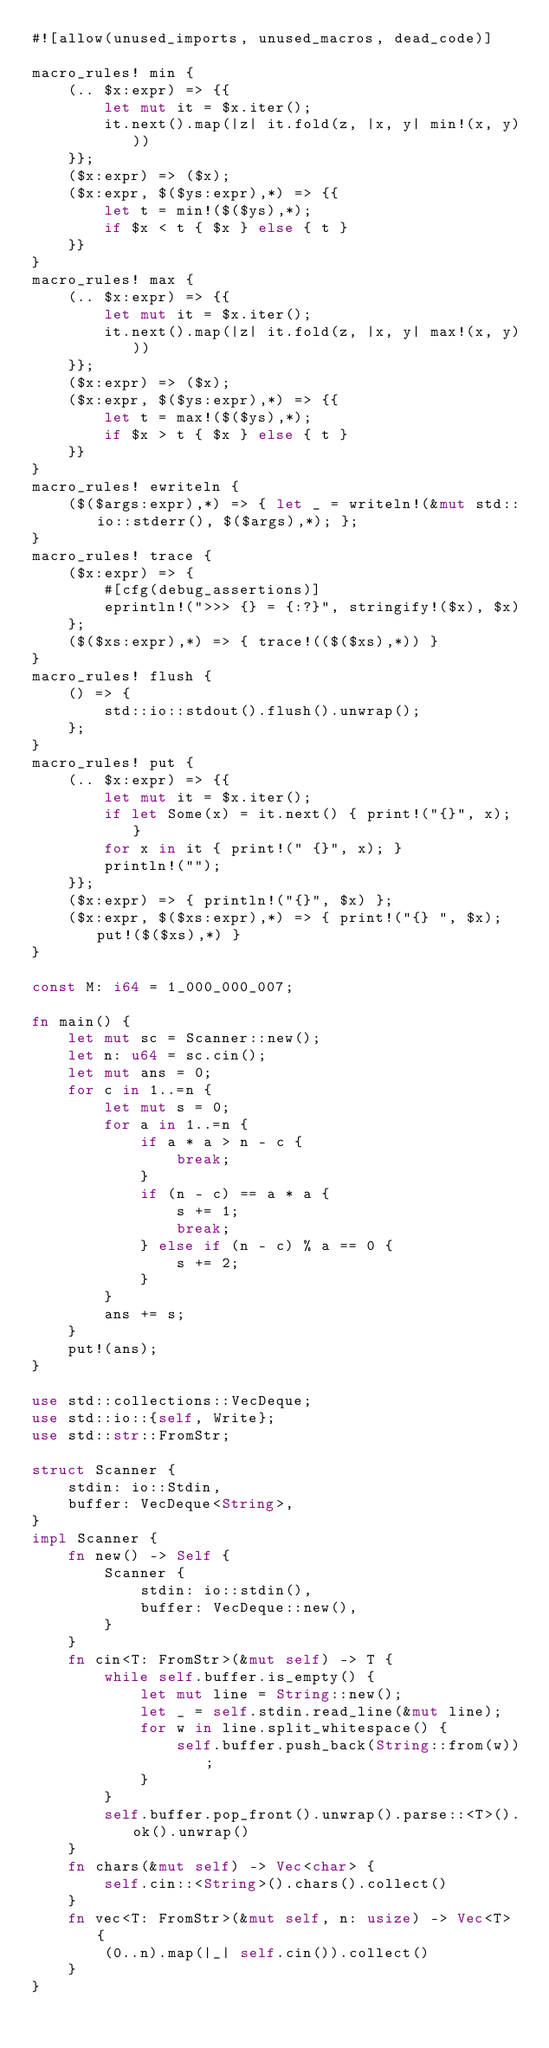<code> <loc_0><loc_0><loc_500><loc_500><_Rust_>#![allow(unused_imports, unused_macros, dead_code)]

macro_rules! min {
    (.. $x:expr) => {{
        let mut it = $x.iter();
        it.next().map(|z| it.fold(z, |x, y| min!(x, y)))
    }};
    ($x:expr) => ($x);
    ($x:expr, $($ys:expr),*) => {{
        let t = min!($($ys),*);
        if $x < t { $x } else { t }
    }}
}
macro_rules! max {
    (.. $x:expr) => {{
        let mut it = $x.iter();
        it.next().map(|z| it.fold(z, |x, y| max!(x, y)))
    }};
    ($x:expr) => ($x);
    ($x:expr, $($ys:expr),*) => {{
        let t = max!($($ys),*);
        if $x > t { $x } else { t }
    }}
}
macro_rules! ewriteln {
    ($($args:expr),*) => { let _ = writeln!(&mut std::io::stderr(), $($args),*); };
}
macro_rules! trace {
    ($x:expr) => {
        #[cfg(debug_assertions)]
        eprintln!(">>> {} = {:?}", stringify!($x), $x)
    };
    ($($xs:expr),*) => { trace!(($($xs),*)) }
}
macro_rules! flush {
    () => {
        std::io::stdout().flush().unwrap();
    };
}
macro_rules! put {
    (.. $x:expr) => {{
        let mut it = $x.iter();
        if let Some(x) = it.next() { print!("{}", x); }
        for x in it { print!(" {}", x); }
        println!("");
    }};
    ($x:expr) => { println!("{}", $x) };
    ($x:expr, $($xs:expr),*) => { print!("{} ", $x); put!($($xs),*) }
}

const M: i64 = 1_000_000_007;

fn main() {
    let mut sc = Scanner::new();
    let n: u64 = sc.cin();
    let mut ans = 0;
    for c in 1..=n {
        let mut s = 0;
        for a in 1..=n {
            if a * a > n - c {
                break;
            }
            if (n - c) == a * a {
                s += 1;
                break;
            } else if (n - c) % a == 0 {
                s += 2;
            }
        }
        ans += s;
    }
    put!(ans);
}

use std::collections::VecDeque;
use std::io::{self, Write};
use std::str::FromStr;

struct Scanner {
    stdin: io::Stdin,
    buffer: VecDeque<String>,
}
impl Scanner {
    fn new() -> Self {
        Scanner {
            stdin: io::stdin(),
            buffer: VecDeque::new(),
        }
    }
    fn cin<T: FromStr>(&mut self) -> T {
        while self.buffer.is_empty() {
            let mut line = String::new();
            let _ = self.stdin.read_line(&mut line);
            for w in line.split_whitespace() {
                self.buffer.push_back(String::from(w));
            }
        }
        self.buffer.pop_front().unwrap().parse::<T>().ok().unwrap()
    }
    fn chars(&mut self) -> Vec<char> {
        self.cin::<String>().chars().collect()
    }
    fn vec<T: FromStr>(&mut self, n: usize) -> Vec<T> {
        (0..n).map(|_| self.cin()).collect()
    }
}
</code> 